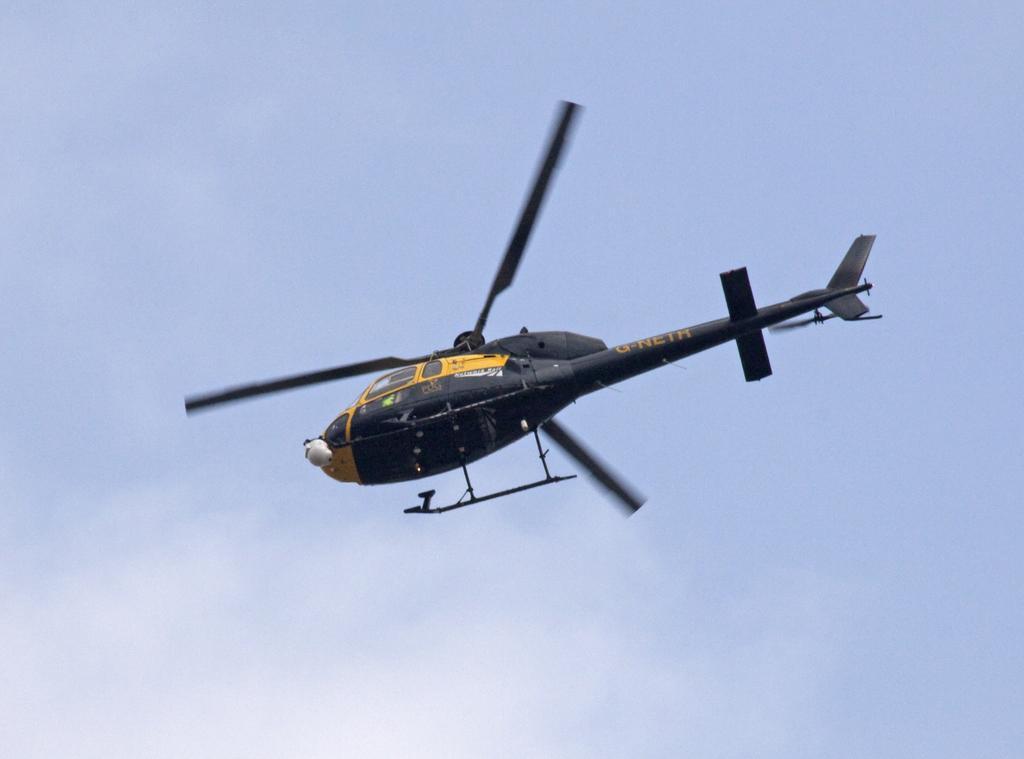How would you summarize this image in a sentence or two? In this image we can see an aircraft. There is the sky in the image. 